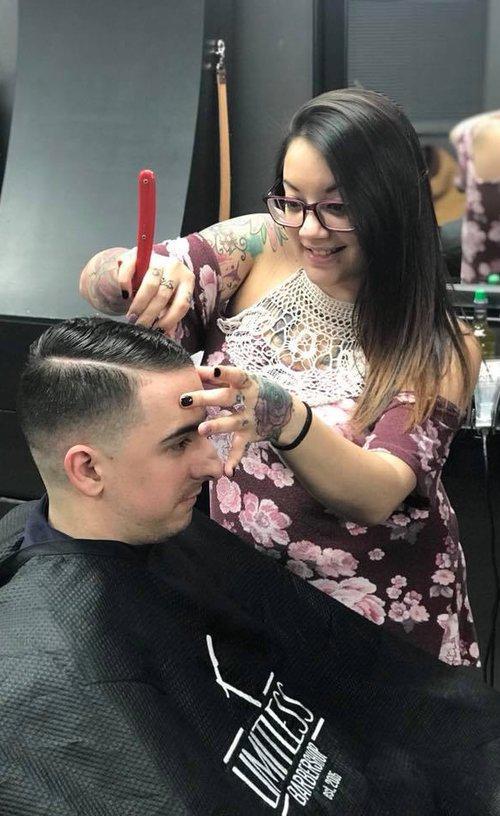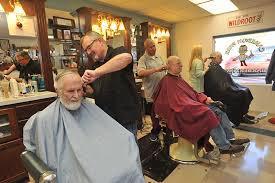The first image is the image on the left, the second image is the image on the right. Examine the images to the left and right. Is the description "A woman works on a man's hair in the image on the left." accurate? Answer yes or no. Yes. The first image is the image on the left, the second image is the image on the right. Considering the images on both sides, is "A woman is working on a man's hair in the left image." valid? Answer yes or no. Yes. 